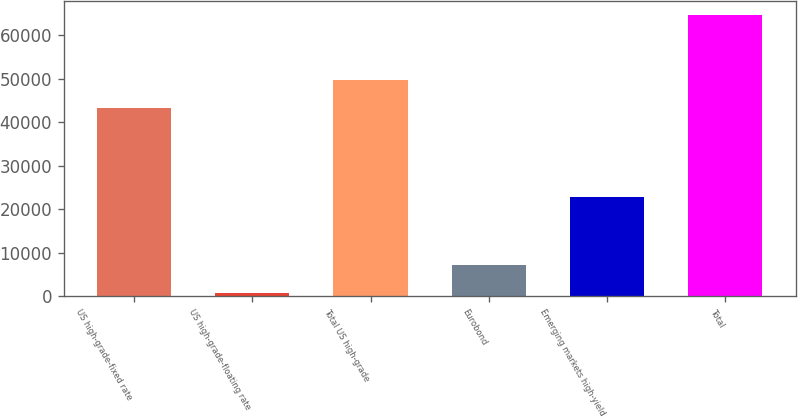Convert chart to OTSL. <chart><loc_0><loc_0><loc_500><loc_500><bar_chart><fcel>US high-grade-fixed rate<fcel>US high-grade-floating rate<fcel>Total US high-grade<fcel>Eurobond<fcel>Emerging markets high-yield<fcel>Total<nl><fcel>43329<fcel>801<fcel>49707.8<fcel>7179.8<fcel>22854<fcel>64589<nl></chart> 